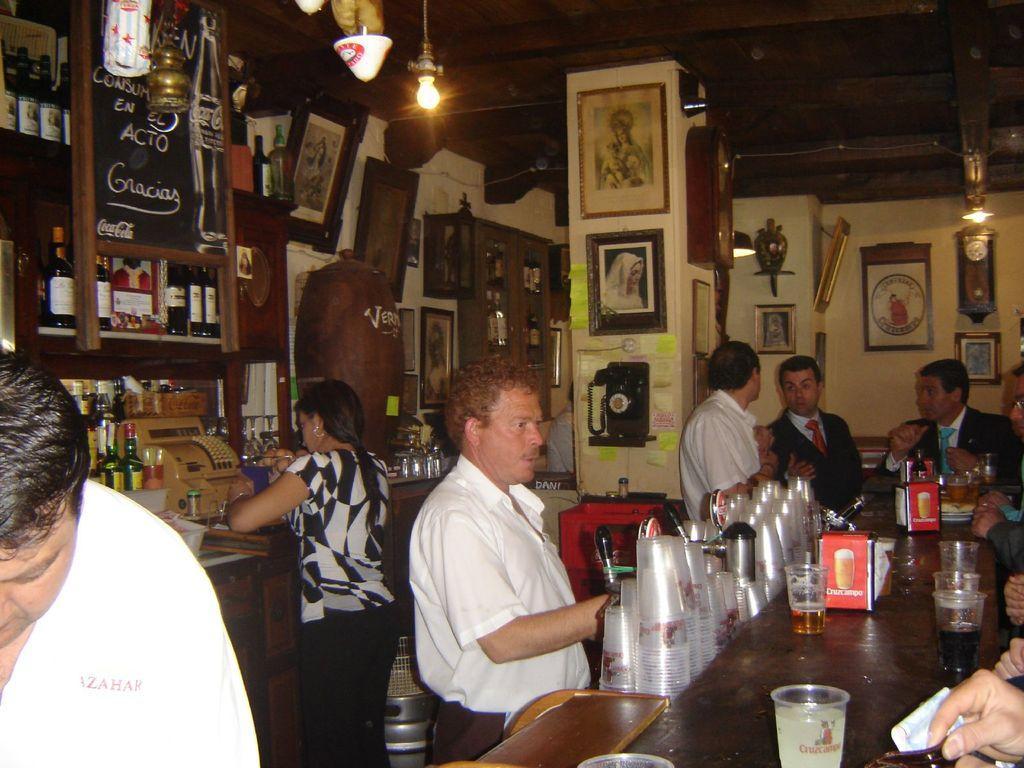Can you describe this image briefly? In this image I can see the group of people with different color dresses. In-front of these people I can see the glasses and the table. On the table I can see the glasses with drink in it, bottle, boards and some objects. To the left I can see the many wine bottles and frames. In the background I can see many frames to the wall and the lights at the top. 